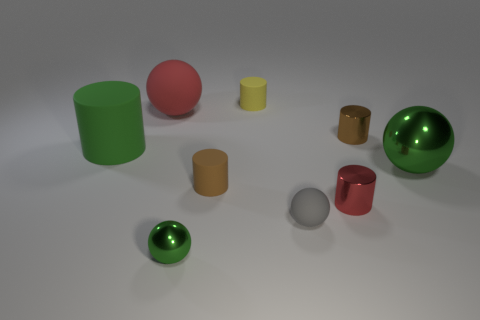Is the shape of the red object behind the large green metal ball the same as  the gray thing?
Offer a very short reply. Yes. How many objects are red metal cylinders on the right side of the large red ball or tiny brown things that are to the right of the small red metal object?
Ensure brevity in your answer.  2. There is a large metallic thing that is the same shape as the gray matte thing; what is its color?
Make the answer very short. Green. Is there anything else that is the same shape as the large green matte object?
Provide a short and direct response. Yes. Is the shape of the tiny yellow rubber thing the same as the red thing on the left side of the tiny gray sphere?
Keep it short and to the point. No. What material is the big red object?
Give a very brief answer. Rubber. There is a red object that is the same shape as the small green object; what size is it?
Provide a succinct answer. Large. How many other objects are the same material as the large green cylinder?
Your answer should be very brief. 4. Do the tiny yellow object and the small brown thing that is left of the small yellow cylinder have the same material?
Your response must be concise. Yes. Is the number of red metal objects that are in front of the tiny green ball less than the number of brown rubber things that are behind the small brown rubber cylinder?
Provide a succinct answer. No. 